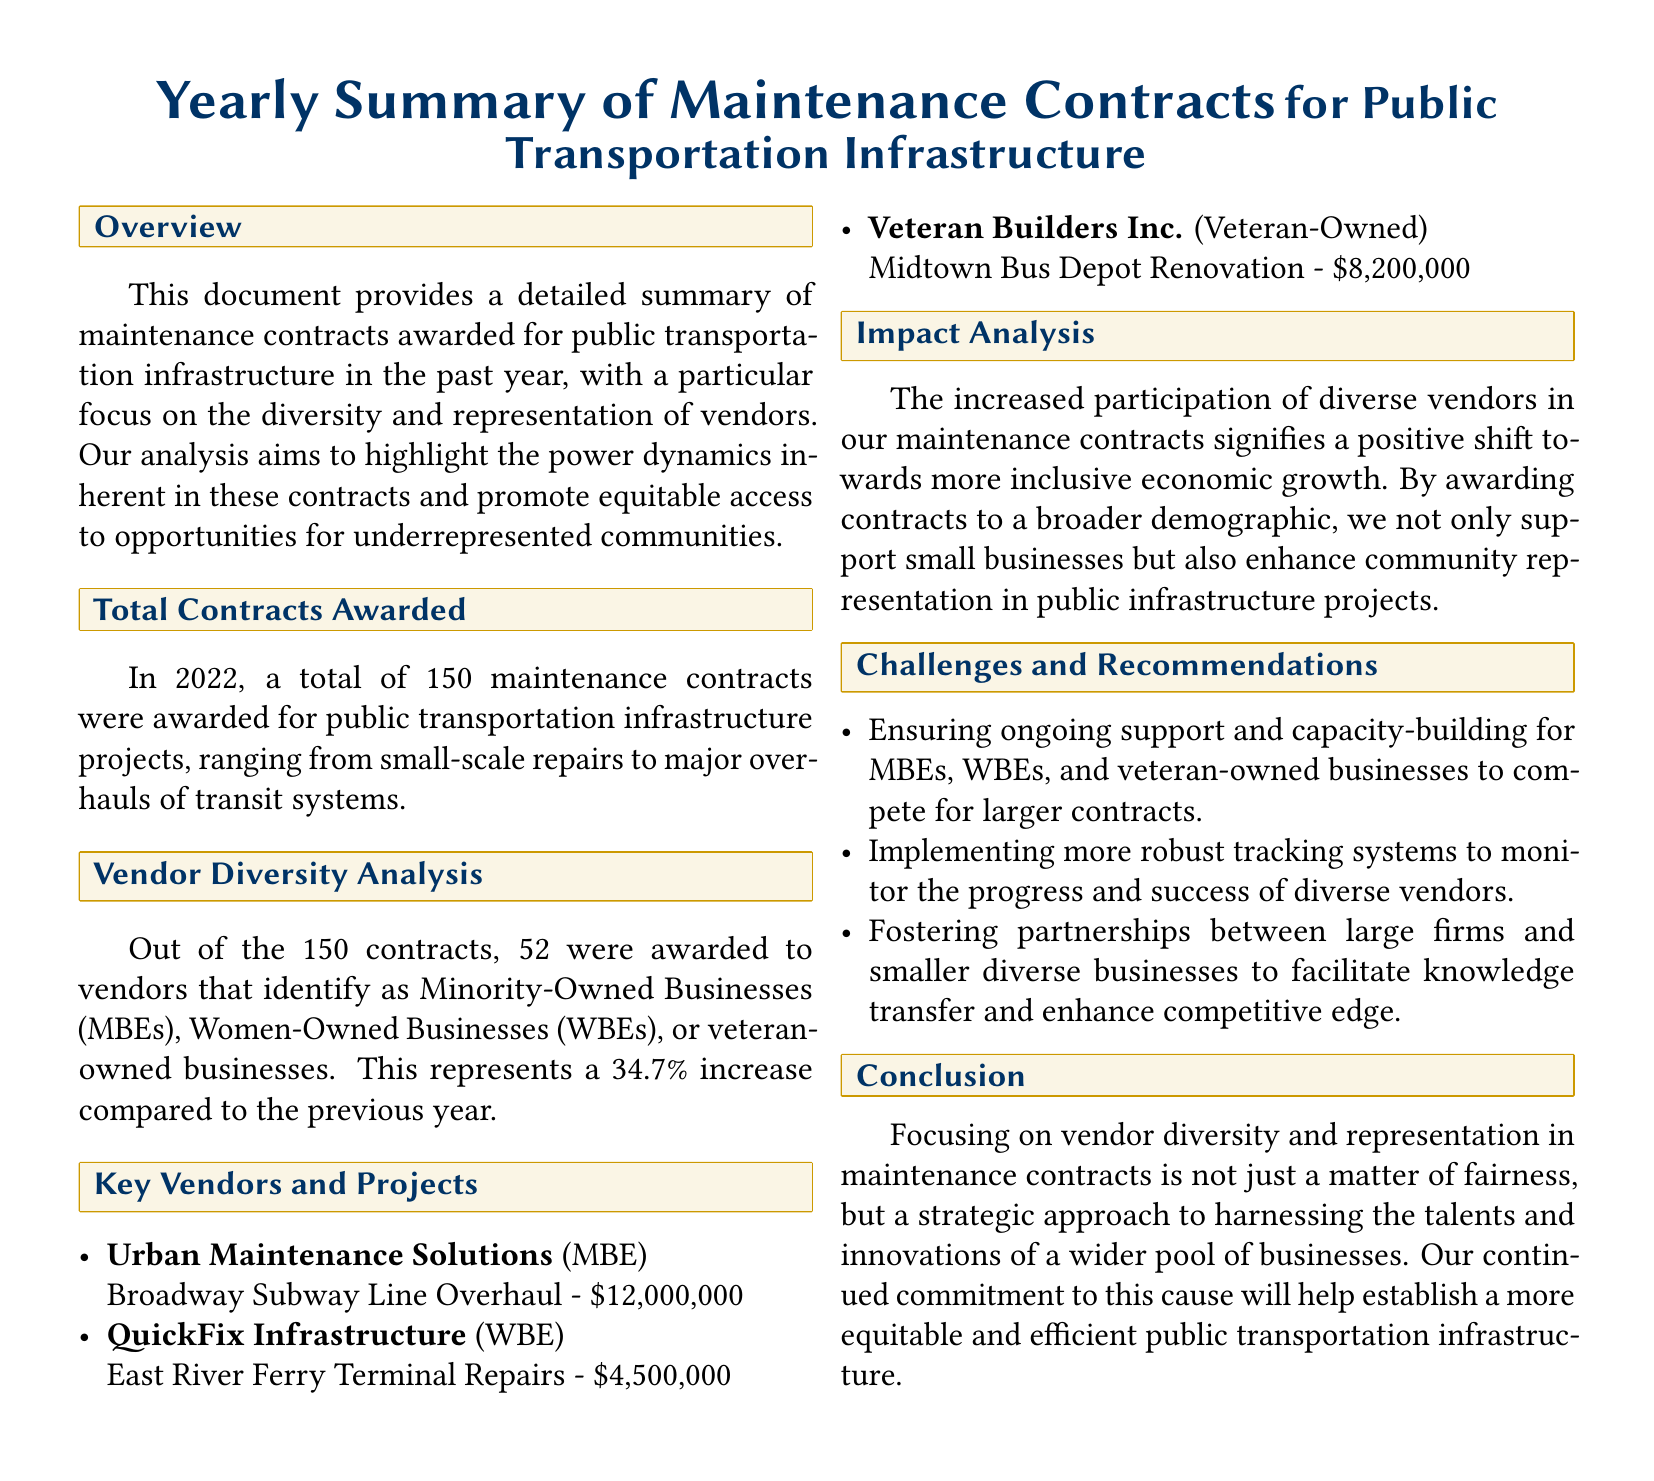What is the total number of contracts awarded in 2022? The total number of contracts awarded is stated in the document as 150.
Answer: 150 How many contracts were awarded to Minority-Owned Businesses? The document states that 52 contracts were awarded to vendors identifying as Minority-Owned, Women-Owned, or veteran-owned businesses.
Answer: 52 What percentage increase in contracts awarded to diverse vendors is reported? The document specifies that the percentage increase in contracts awarded to diverse vendors is 34.7%.
Answer: 34.7% Who was awarded the contract for the Broadway Subway Line Overhaul? The document lists Urban Maintenance Solutions as the vendor for the Broadway Subway Line Overhaul.
Answer: Urban Maintenance Solutions What is a key recommendation mentioned for supporting diverse vendors? The document recommends ensuring ongoing support and capacity-building for diverse businesses to compete for larger contracts.
Answer: Ongoing support and capacity-building What type of business is QuickFix Infrastructure categorized as? The document categorizes QuickFix Infrastructure as a Women-Owned Business.
Answer: Women-Owned Business What is the financial value of the East River Ferry Terminal Repairs contract? The financial value of the contract for the East River Ferry Terminal Repairs is provided as $4,500,000.
Answer: $4,500,000 How does the document describe the impact of increased vendor diversity? The document states that increased vendor diversity signifies a positive shift towards more inclusive economic growth.
Answer: Positive shift towards more inclusive economic growth 